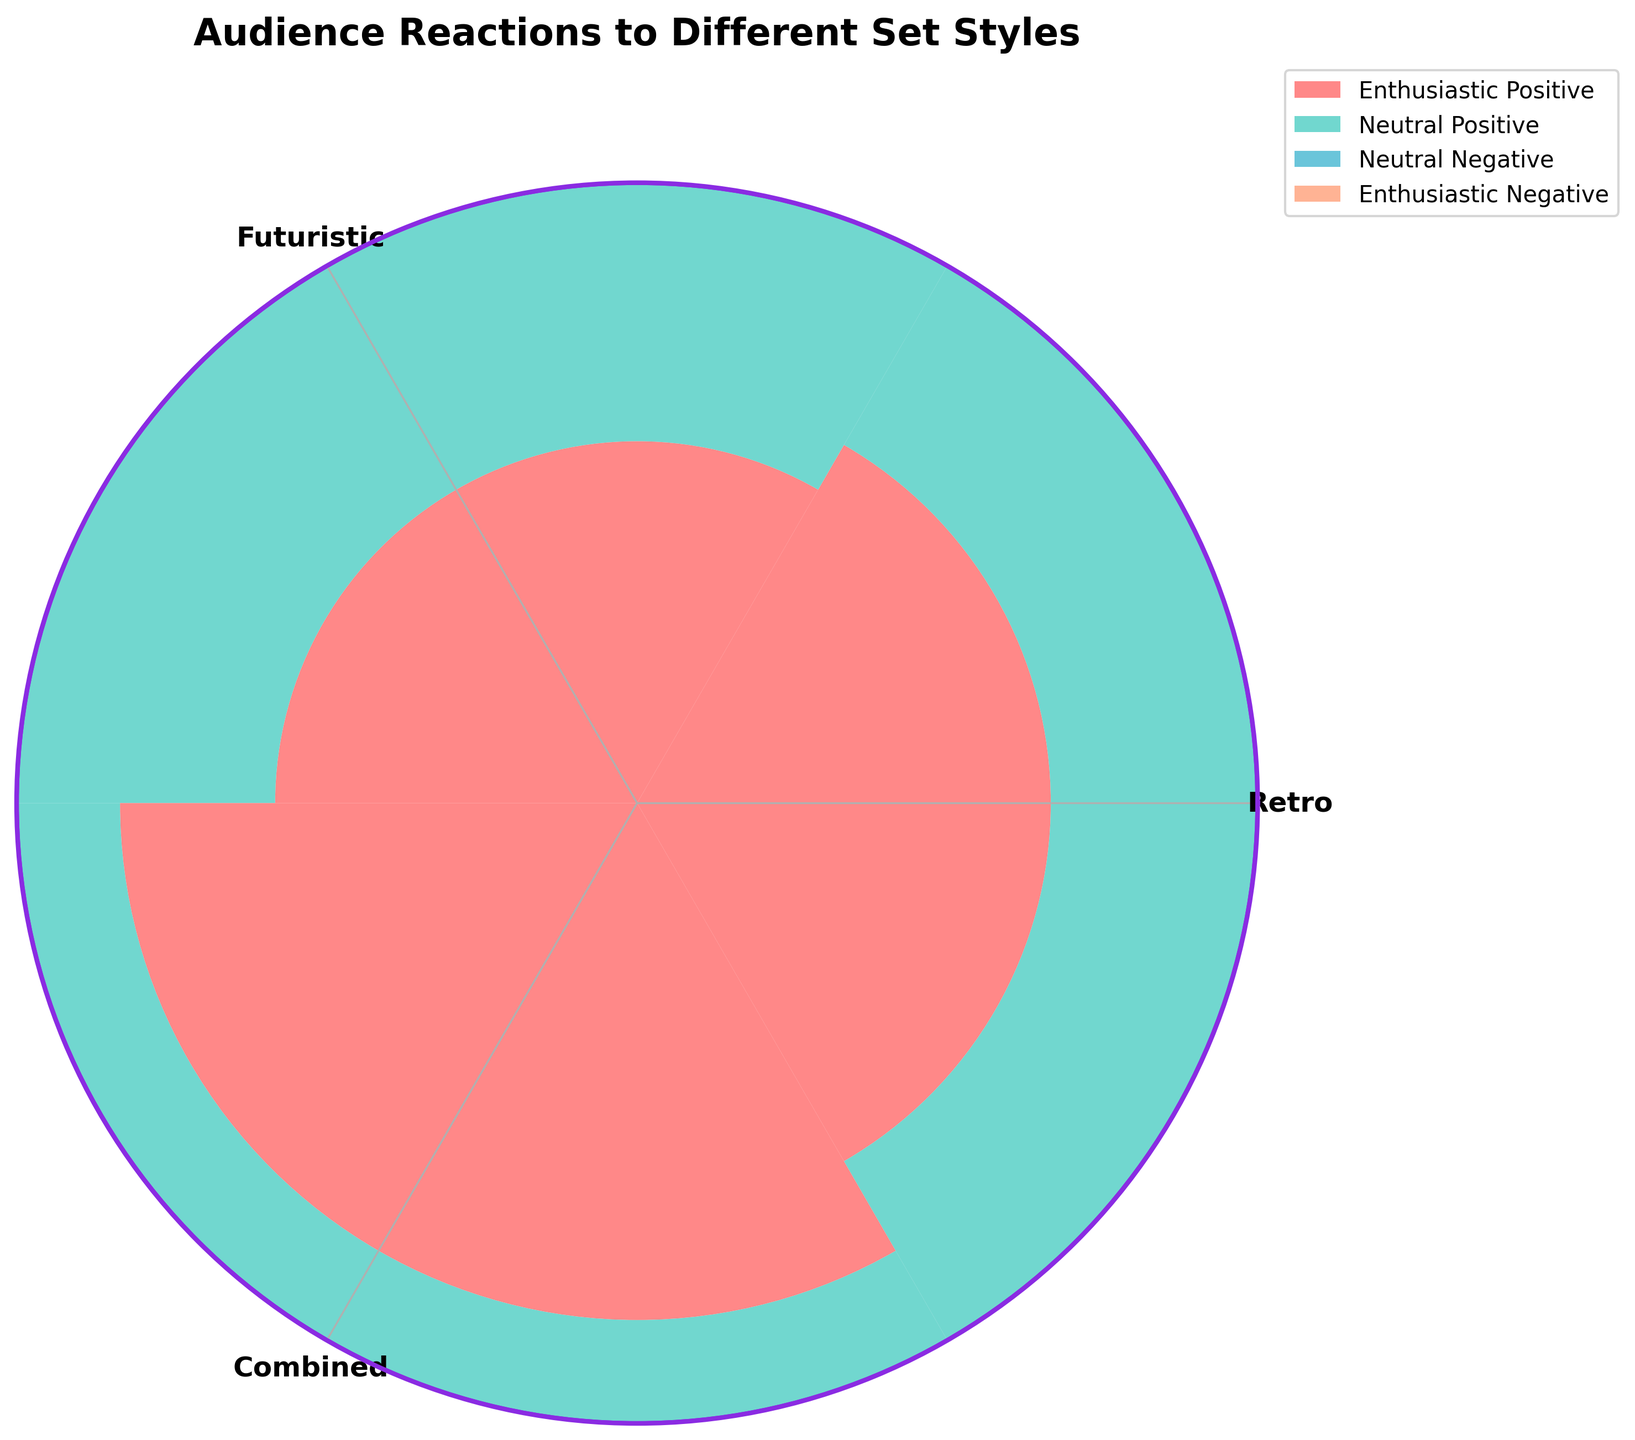Which set style has the highest number of enthusiastic positive reactions? By observing the chart, look at the section representing enthusiastic positive reactions and compare among Retro, Futuristic, and Combined styles. The largest section will indicate the highest number.
Answer: Combined Which set style has the lowest number of neutral negative reactions? Look at the sections of the chart corresponding to neutral negative reactions for each style. Identify the smallest section.
Answer: Combined How many total reactions does the Retro style receive? Add up the different reactions for the Retro style: 40 (enthusiastic positive) + 30 (neutral positive) + 20 (neutral negative) + 10 (enthusiastic negative).
Answer: 100 Which reactions show a larger difference between Retro and Futuristic styles? Compare the values for each reaction category: enthusiastic positive (5 difference), neutral positive (5 difference), neutral negative (5 difference), and enthusiastic negative (5 difference). Since all differences are equal, we can select any or list multiple.
Answer: All reactions with 5 Which style has the most evenly distributed reactions among the four categories? Examine the widths of segments within each style. The style with nearly equal segment sizes across the four categories will be the most evenly distributed.
Answer: Futuristic For the Reactive Style, what is the difference in numbers between enthusiastic positive and enthusiastic negative reactions? Subtract the number of enthusiastic negative reactions from enthusiastic positive reactions for Retro (40 - 10 = 30).
Answer: 30 Which set style has the smallest proportion of neutral positive reactions relative to its total reactions? Calculate the proportion of neutral positive reactions relative to total reactions for each style: Retro (30/100), Futuristic (25/100), Combined (20/100). Identify the smallest proportion.
Answer: Combined By how much do enthusiastic positive reactions for Retro exceed those for Futuristic style? Subtract the enthusiastic positive reactions of Futuristic from Retro (40 - 35 = 5).
Answer: 5 What proportion of the total enthusiastic positive reactions does the Combined style represent? Calculate the total enthusiastic positive reactions across all styles (40 + 35 + 50 = 125). Then find the proportion for Combined (50/125 = 0.4).
Answer: 40% How does the number of neutral negative reactions in Combined compare to Futuristic? Compare the number of neutral negative reactions directly: Combined (15), Futuristic (25).
Answer: Combined has 10 fewer reactions 